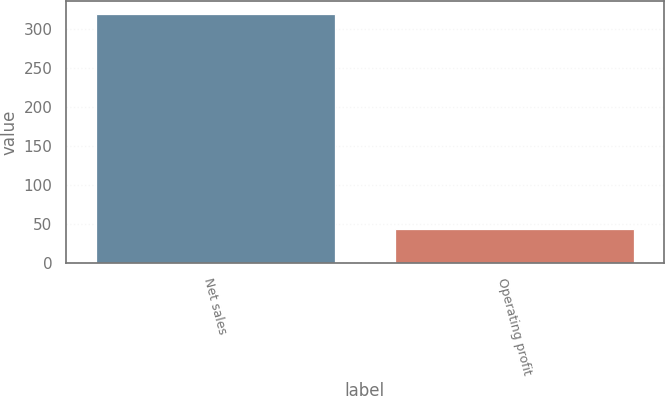<chart> <loc_0><loc_0><loc_500><loc_500><bar_chart><fcel>Net sales<fcel>Operating profit<nl><fcel>320<fcel>44<nl></chart> 